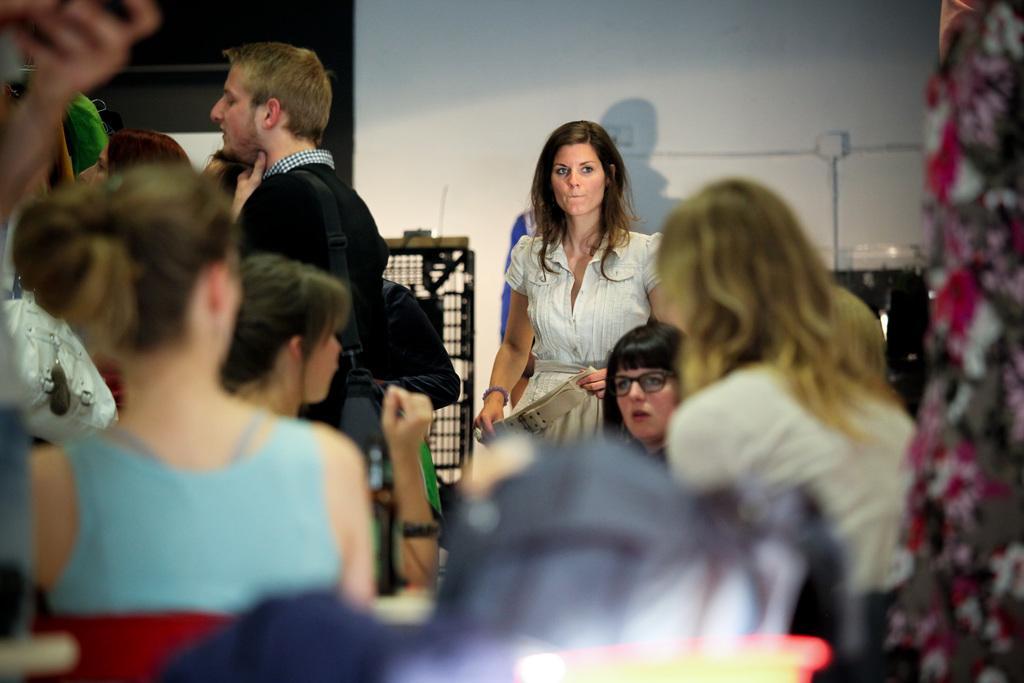How would you summarize this image in a sentence or two? There are people in the foreground area of the image, there is an object at the bottom side, there is a wall, it seems like a net in the background, it seems like a curtain on the right side. 